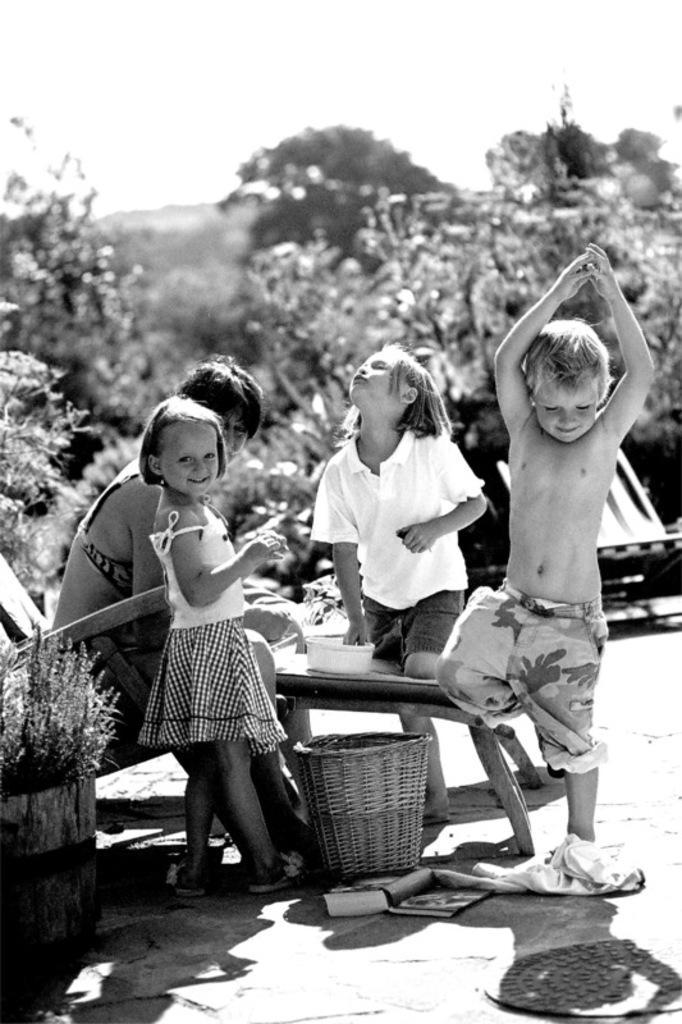How would you summarize this image in a sentence or two? This picture is clicked outside. On the right there is a Boy standing and looking on the ground. In the center there is a Girl wearing white color shirt and standing. There is a bowl placed at the top of the table. There is a basket placed on the ground and there is a book lying on the ground. On the left there is a Woman sitting on the rocking chair and there is a Girl standing and smiling. On the left corner there is a Houseplant. In the background we can see the Sky and Trees. 